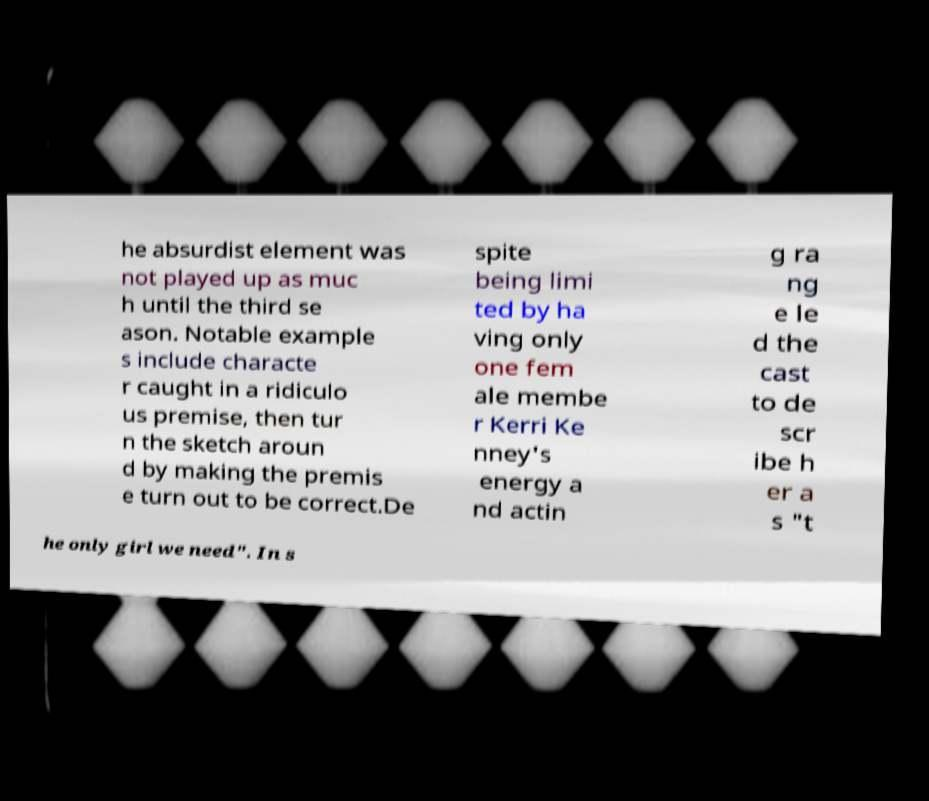Could you extract and type out the text from this image? he absurdist element was not played up as muc h until the third se ason. Notable example s include characte r caught in a ridiculo us premise, then tur n the sketch aroun d by making the premis e turn out to be correct.De spite being limi ted by ha ving only one fem ale membe r Kerri Ke nney's energy a nd actin g ra ng e le d the cast to de scr ibe h er a s "t he only girl we need". In s 